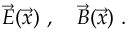<formula> <loc_0><loc_0><loc_500><loc_500>\vec { E } ( \vec { x } ) \ , \quad \vec { B } ( \vec { x } ) \ .</formula> 